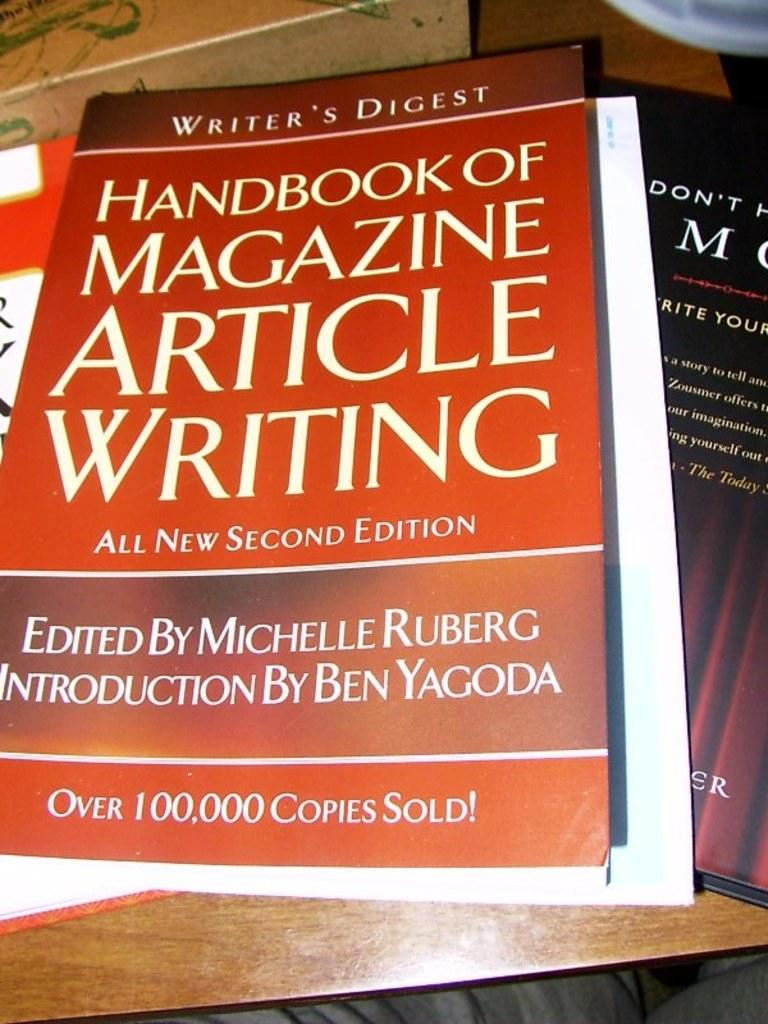<image>
Provide a brief description of the given image. The Handbook Of Magazine Article Writing is sitting on a wooden table, on top of other publications. 